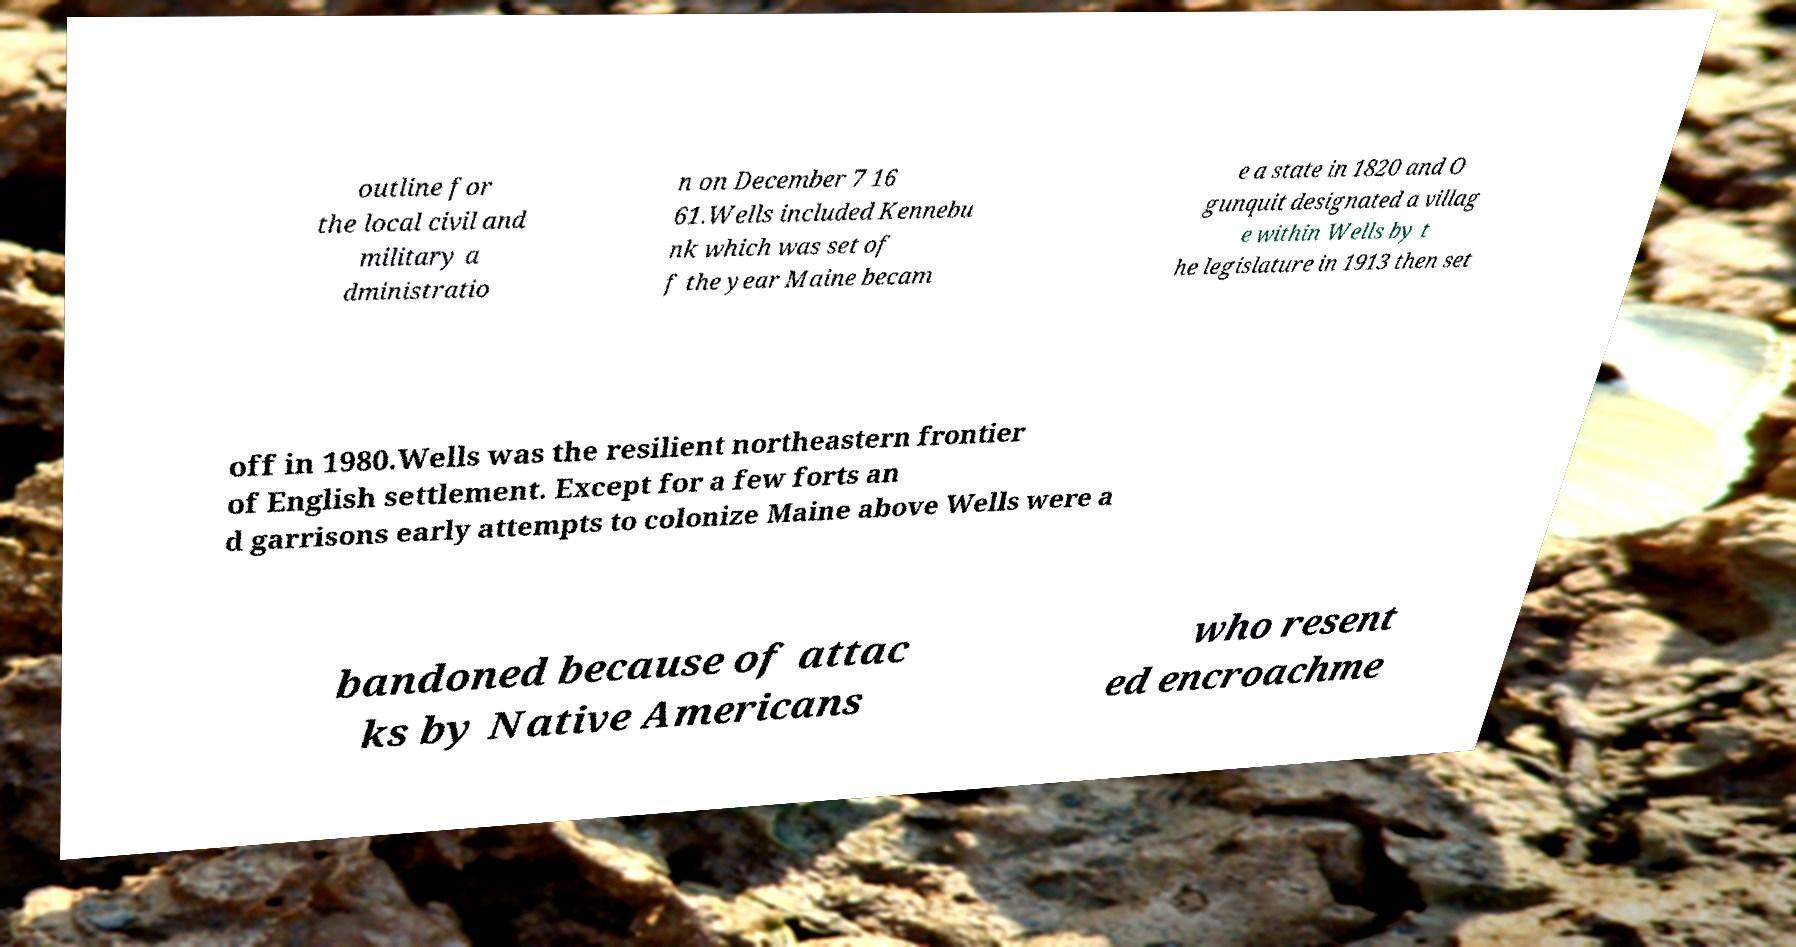Could you extract and type out the text from this image? outline for the local civil and military a dministratio n on December 7 16 61.Wells included Kennebu nk which was set of f the year Maine becam e a state in 1820 and O gunquit designated a villag e within Wells by t he legislature in 1913 then set off in 1980.Wells was the resilient northeastern frontier of English settlement. Except for a few forts an d garrisons early attempts to colonize Maine above Wells were a bandoned because of attac ks by Native Americans who resent ed encroachme 